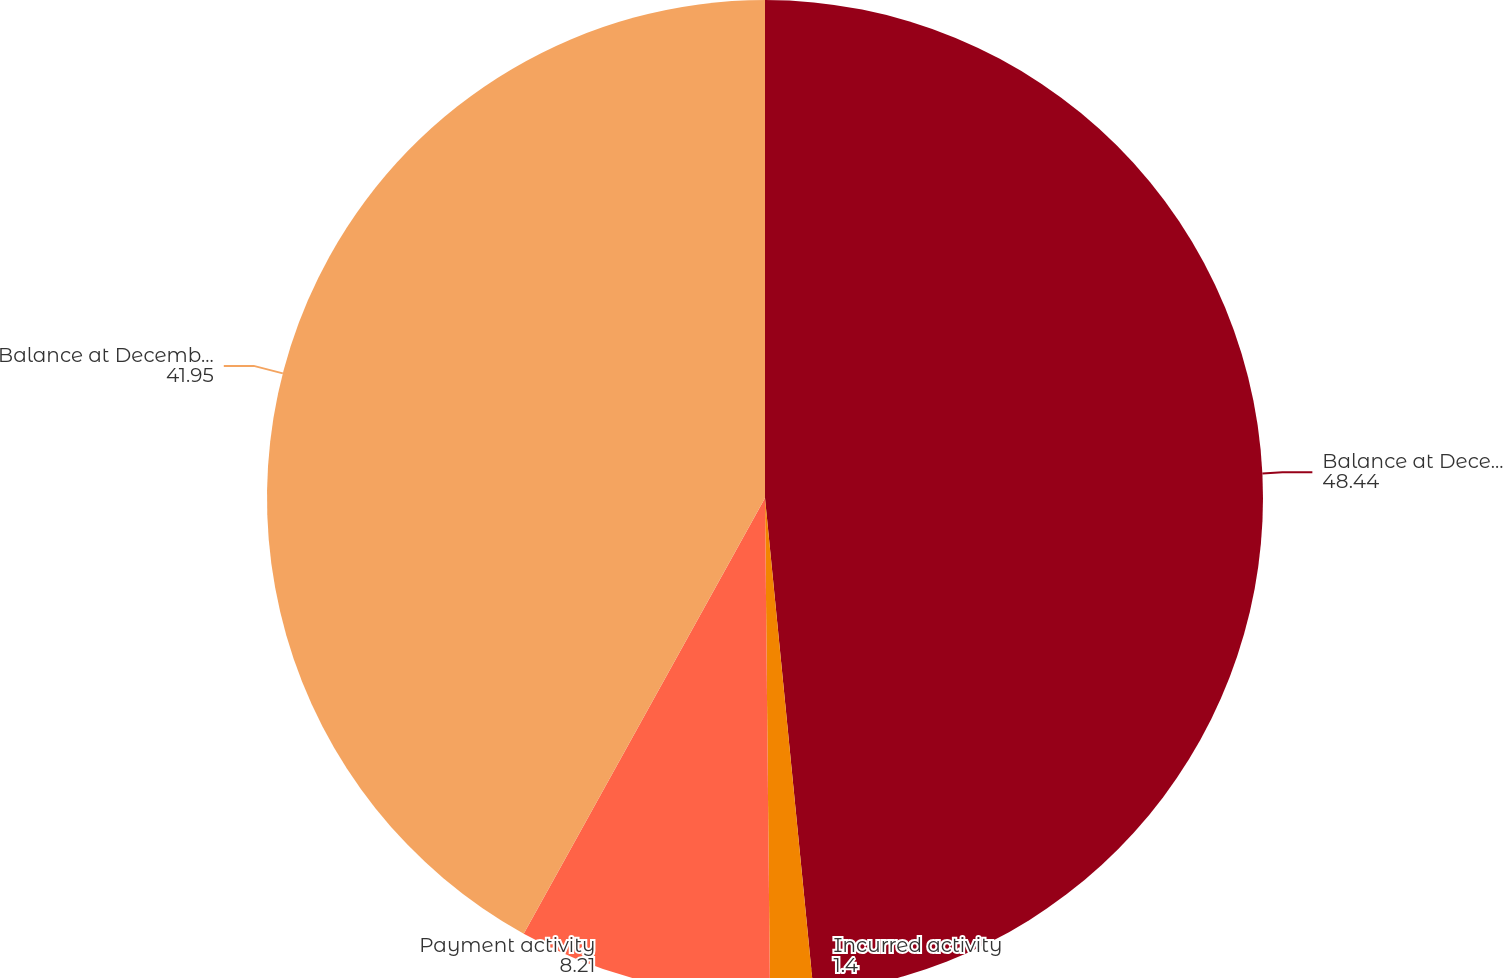Convert chart. <chart><loc_0><loc_0><loc_500><loc_500><pie_chart><fcel>Balance at December 31 2008<fcel>Incurred activity<fcel>Payment activity<fcel>Balance at December 31 2009<nl><fcel>48.44%<fcel>1.4%<fcel>8.21%<fcel>41.95%<nl></chart> 